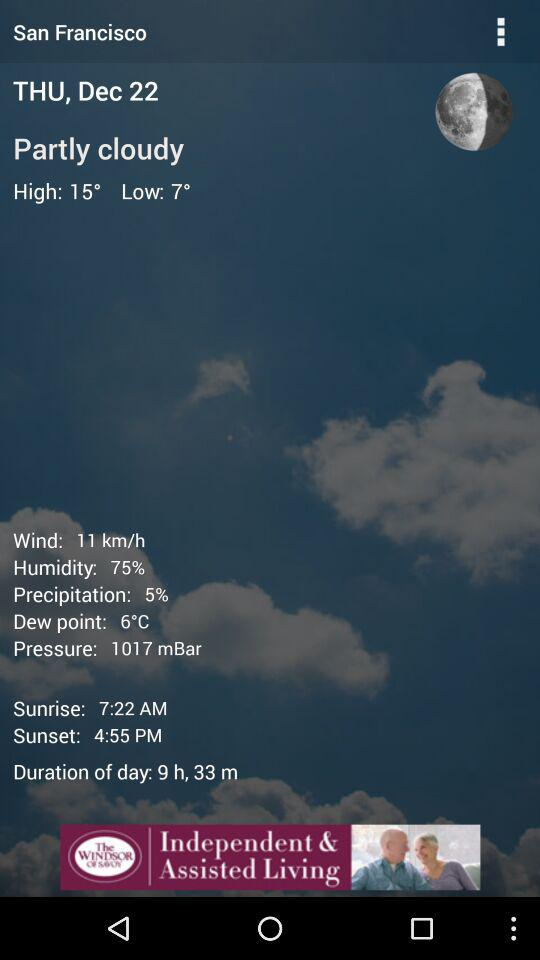What is the name of the city? The name of the city is San Francisco. 